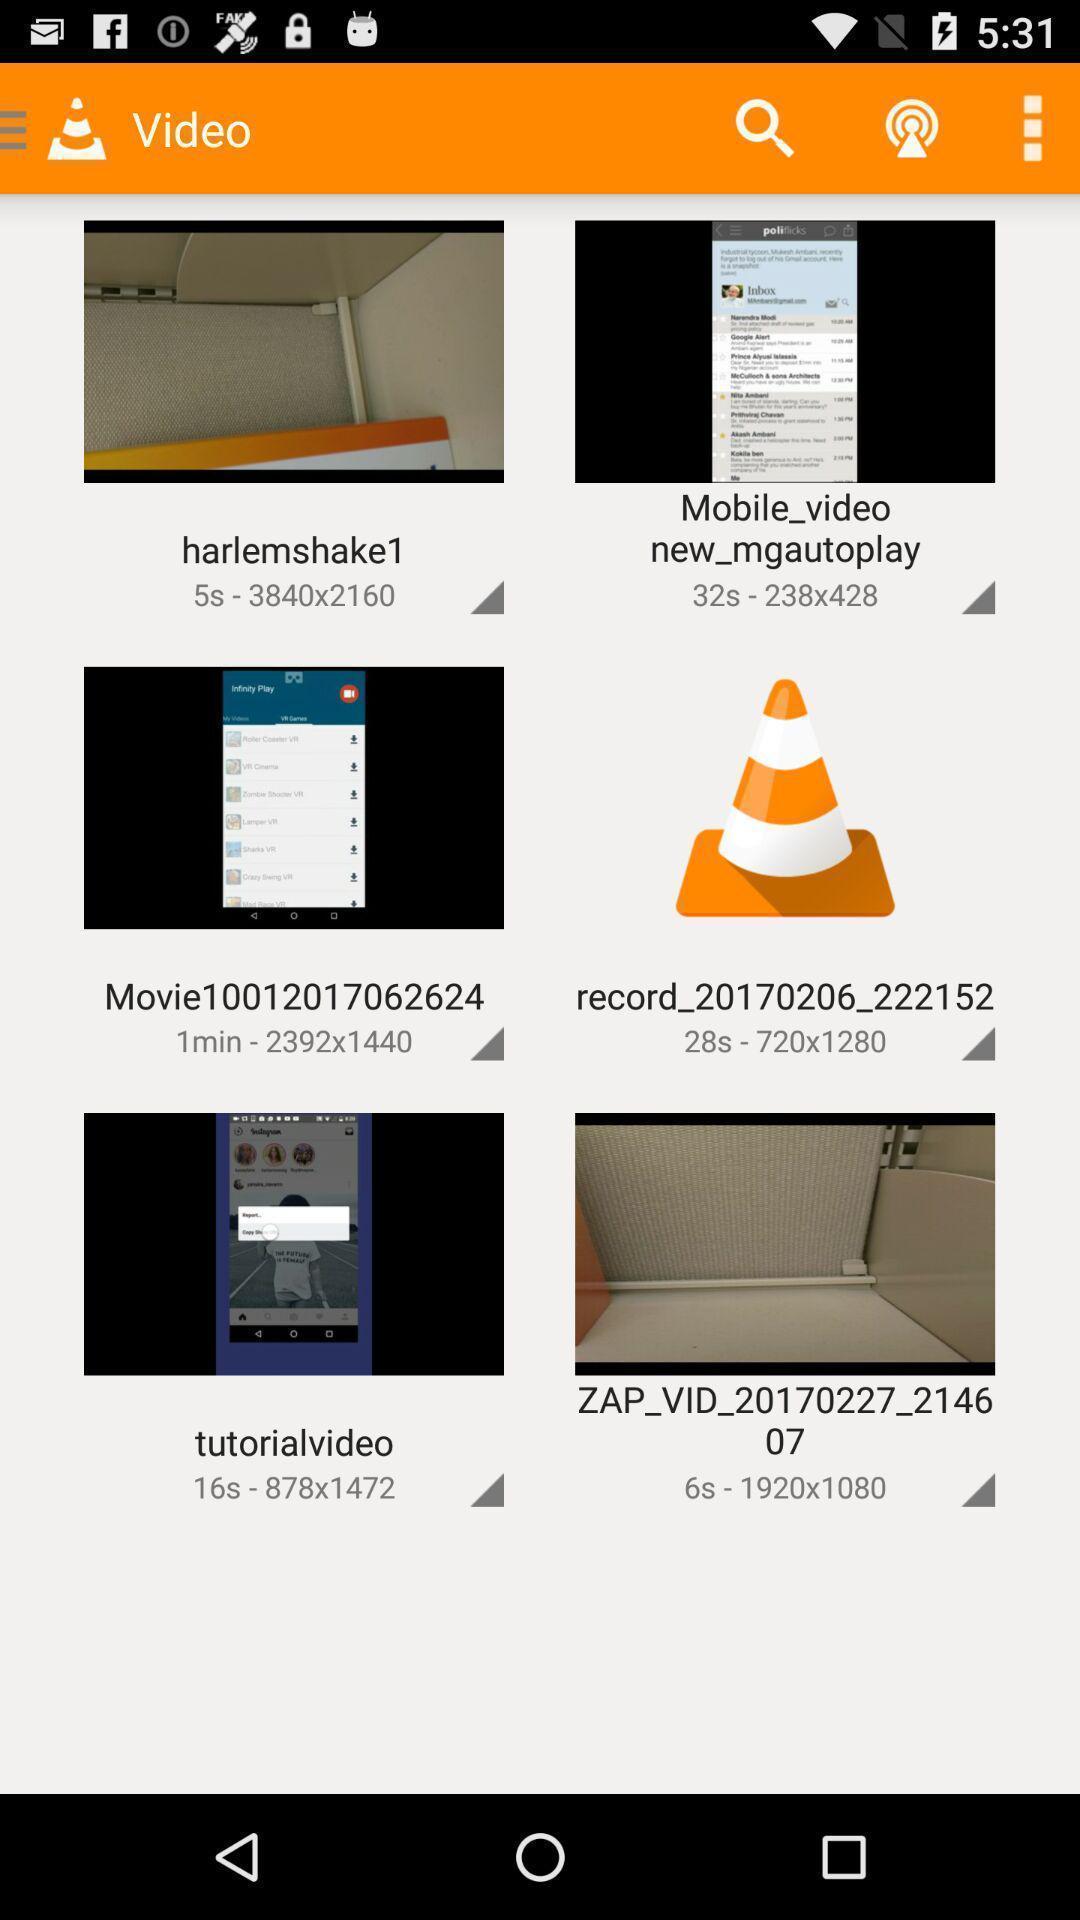Tell me about the visual elements in this screen capture. Page showing different videos. 